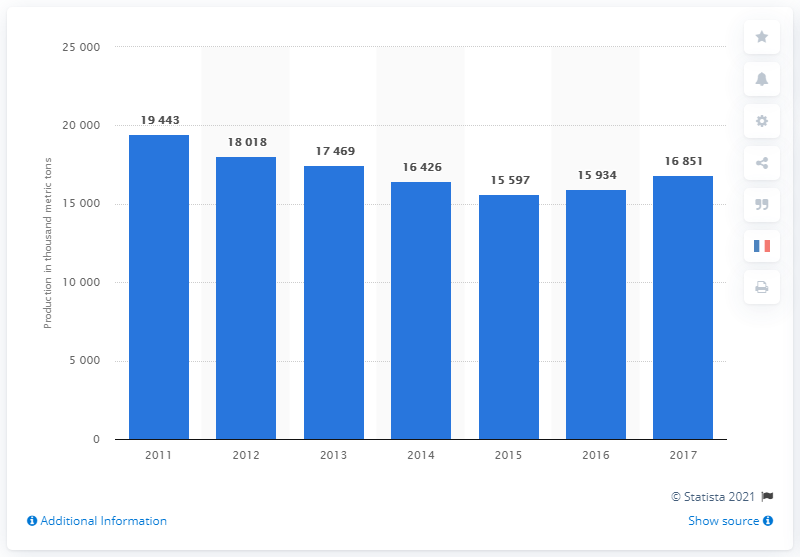Indicate a few pertinent items in this graphic. The average of 2015, 2016, and 2017 (in 1,000 metric tons) is 16,127. In 2015, the production was closest to 15,500. 